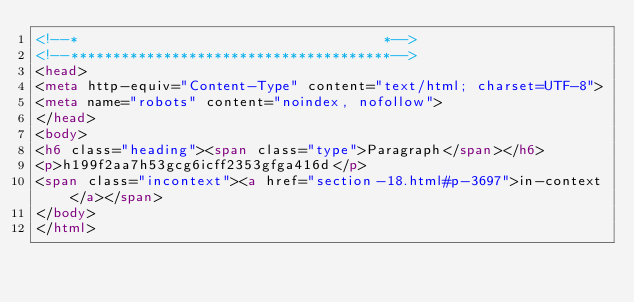<code> <loc_0><loc_0><loc_500><loc_500><_HTML_><!--*                                    *-->
<!--**************************************-->
<head>
<meta http-equiv="Content-Type" content="text/html; charset=UTF-8">
<meta name="robots" content="noindex, nofollow">
</head>
<body>
<h6 class="heading"><span class="type">Paragraph</span></h6>
<p>h199f2aa7h53gcg6icff2353gfga416d</p>
<span class="incontext"><a href="section-18.html#p-3697">in-context</a></span>
</body>
</html>
</code> 